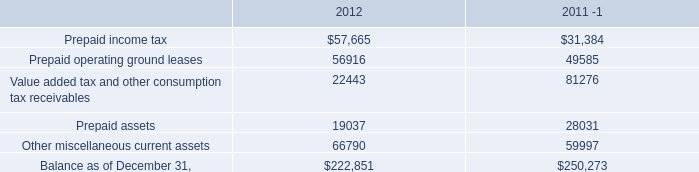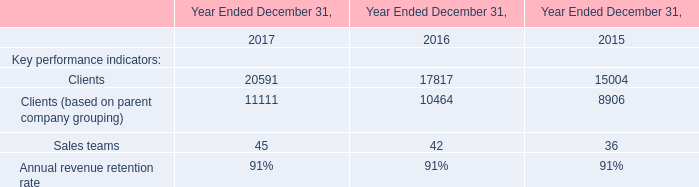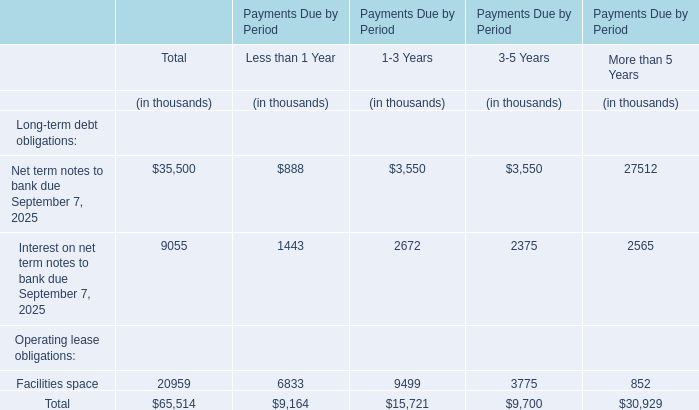for 2012 , tax related assets were how much of total current assets and prepaids?\\n\\n 
Computations: ((57665 + 22443) / 222851)
Answer: 0.35947. 